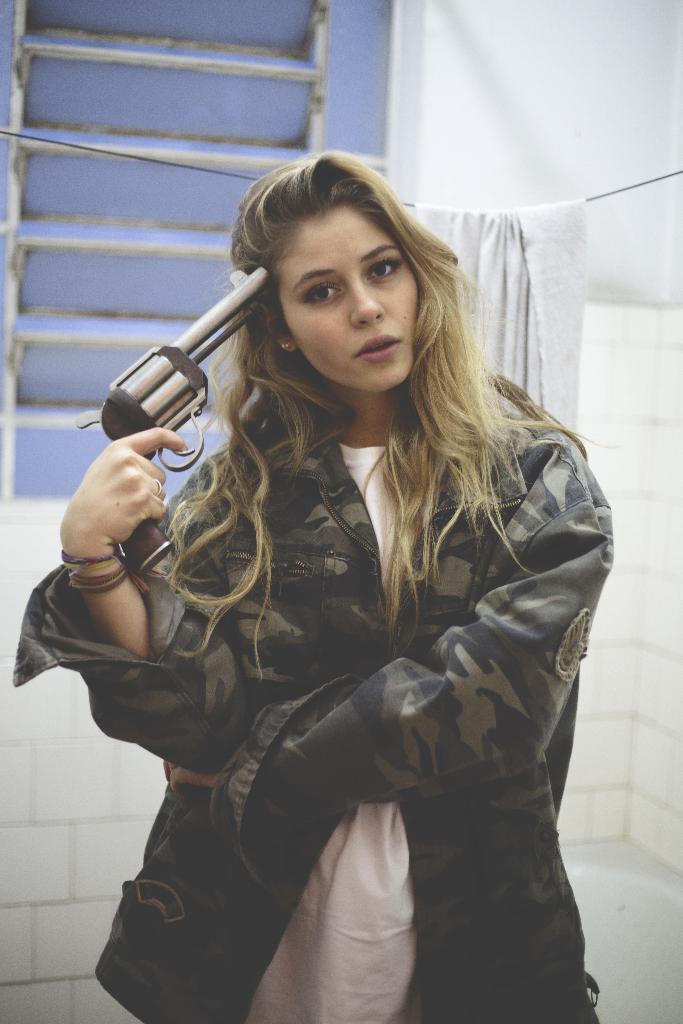Could you give a brief overview of what you see in this image? In this image I can see a woman holding a gun. In the background, I can see a cloth hanging on the wire. I can also see the wall. 